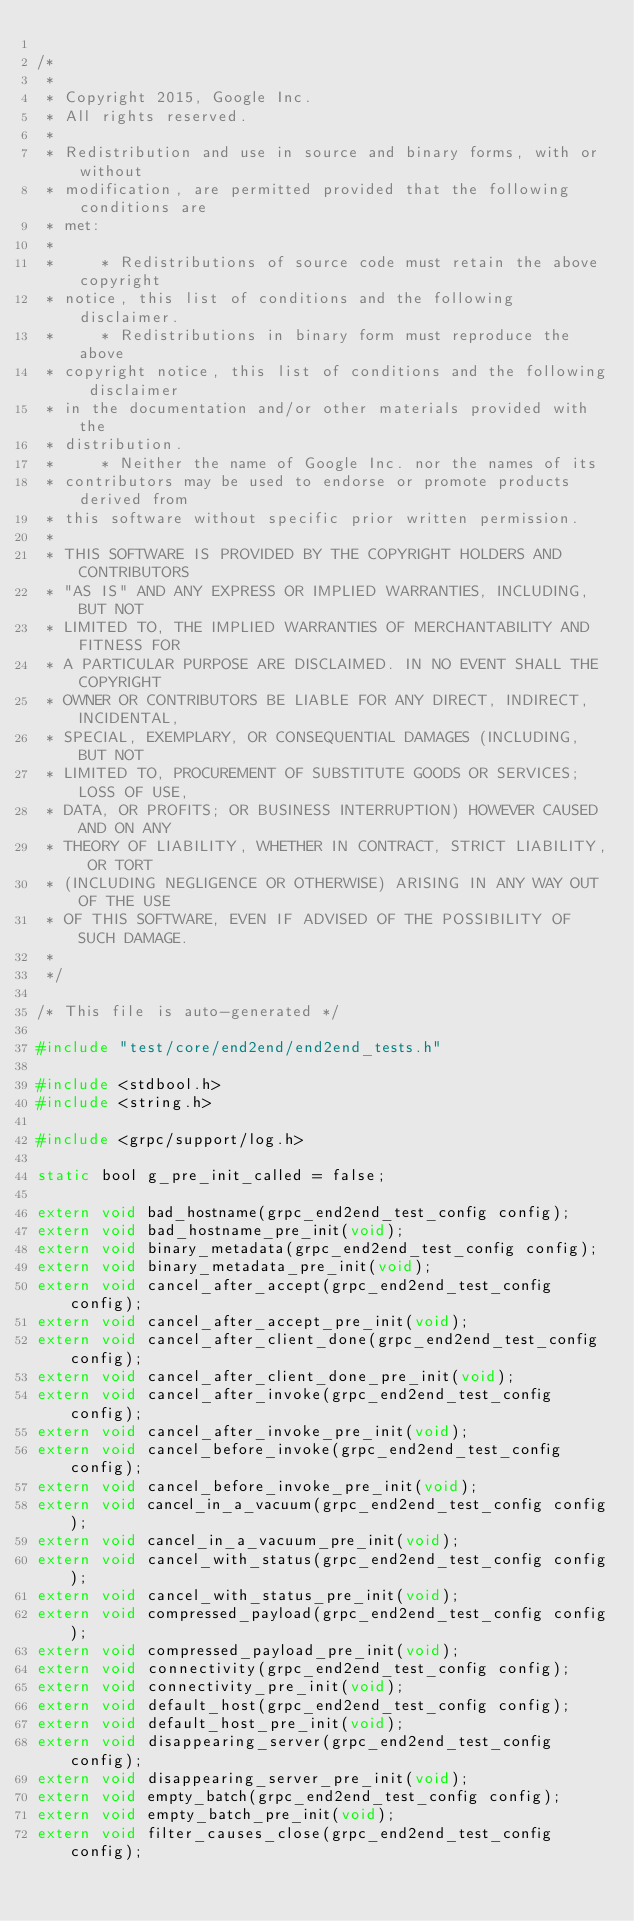Convert code to text. <code><loc_0><loc_0><loc_500><loc_500><_C_>
/*
 *
 * Copyright 2015, Google Inc.
 * All rights reserved.
 *
 * Redistribution and use in source and binary forms, with or without
 * modification, are permitted provided that the following conditions are
 * met:
 *
 *     * Redistributions of source code must retain the above copyright
 * notice, this list of conditions and the following disclaimer.
 *     * Redistributions in binary form must reproduce the above
 * copyright notice, this list of conditions and the following disclaimer
 * in the documentation and/or other materials provided with the
 * distribution.
 *     * Neither the name of Google Inc. nor the names of its
 * contributors may be used to endorse or promote products derived from
 * this software without specific prior written permission.
 *
 * THIS SOFTWARE IS PROVIDED BY THE COPYRIGHT HOLDERS AND CONTRIBUTORS
 * "AS IS" AND ANY EXPRESS OR IMPLIED WARRANTIES, INCLUDING, BUT NOT
 * LIMITED TO, THE IMPLIED WARRANTIES OF MERCHANTABILITY AND FITNESS FOR
 * A PARTICULAR PURPOSE ARE DISCLAIMED. IN NO EVENT SHALL THE COPYRIGHT
 * OWNER OR CONTRIBUTORS BE LIABLE FOR ANY DIRECT, INDIRECT, INCIDENTAL,
 * SPECIAL, EXEMPLARY, OR CONSEQUENTIAL DAMAGES (INCLUDING, BUT NOT
 * LIMITED TO, PROCUREMENT OF SUBSTITUTE GOODS OR SERVICES; LOSS OF USE,
 * DATA, OR PROFITS; OR BUSINESS INTERRUPTION) HOWEVER CAUSED AND ON ANY
 * THEORY OF LIABILITY, WHETHER IN CONTRACT, STRICT LIABILITY, OR TORT
 * (INCLUDING NEGLIGENCE OR OTHERWISE) ARISING IN ANY WAY OUT OF THE USE
 * OF THIS SOFTWARE, EVEN IF ADVISED OF THE POSSIBILITY OF SUCH DAMAGE.
 *
 */

/* This file is auto-generated */

#include "test/core/end2end/end2end_tests.h"

#include <stdbool.h>
#include <string.h>

#include <grpc/support/log.h>

static bool g_pre_init_called = false;

extern void bad_hostname(grpc_end2end_test_config config);
extern void bad_hostname_pre_init(void);
extern void binary_metadata(grpc_end2end_test_config config);
extern void binary_metadata_pre_init(void);
extern void cancel_after_accept(grpc_end2end_test_config config);
extern void cancel_after_accept_pre_init(void);
extern void cancel_after_client_done(grpc_end2end_test_config config);
extern void cancel_after_client_done_pre_init(void);
extern void cancel_after_invoke(grpc_end2end_test_config config);
extern void cancel_after_invoke_pre_init(void);
extern void cancel_before_invoke(grpc_end2end_test_config config);
extern void cancel_before_invoke_pre_init(void);
extern void cancel_in_a_vacuum(grpc_end2end_test_config config);
extern void cancel_in_a_vacuum_pre_init(void);
extern void cancel_with_status(grpc_end2end_test_config config);
extern void cancel_with_status_pre_init(void);
extern void compressed_payload(grpc_end2end_test_config config);
extern void compressed_payload_pre_init(void);
extern void connectivity(grpc_end2end_test_config config);
extern void connectivity_pre_init(void);
extern void default_host(grpc_end2end_test_config config);
extern void default_host_pre_init(void);
extern void disappearing_server(grpc_end2end_test_config config);
extern void disappearing_server_pre_init(void);
extern void empty_batch(grpc_end2end_test_config config);
extern void empty_batch_pre_init(void);
extern void filter_causes_close(grpc_end2end_test_config config);</code> 